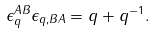Convert formula to latex. <formula><loc_0><loc_0><loc_500><loc_500>\epsilon _ { q } ^ { A B } \epsilon _ { q , B A } = q + q ^ { - 1 } .</formula> 